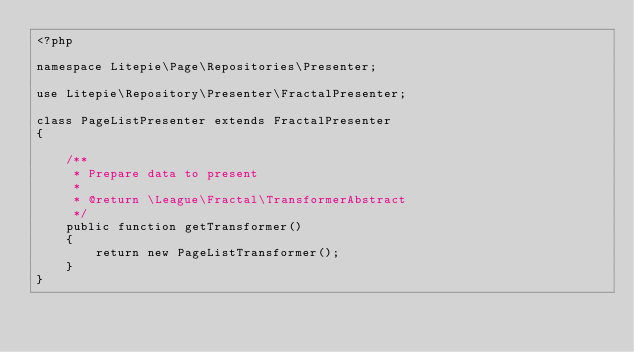Convert code to text. <code><loc_0><loc_0><loc_500><loc_500><_PHP_><?php

namespace Litepie\Page\Repositories\Presenter;

use Litepie\Repository\Presenter\FractalPresenter;

class PageListPresenter extends FractalPresenter
{

    /**
     * Prepare data to present
     *
     * @return \League\Fractal\TransformerAbstract
     */
    public function getTransformer()
    {
        return new PageListTransformer();
    }
}
</code> 